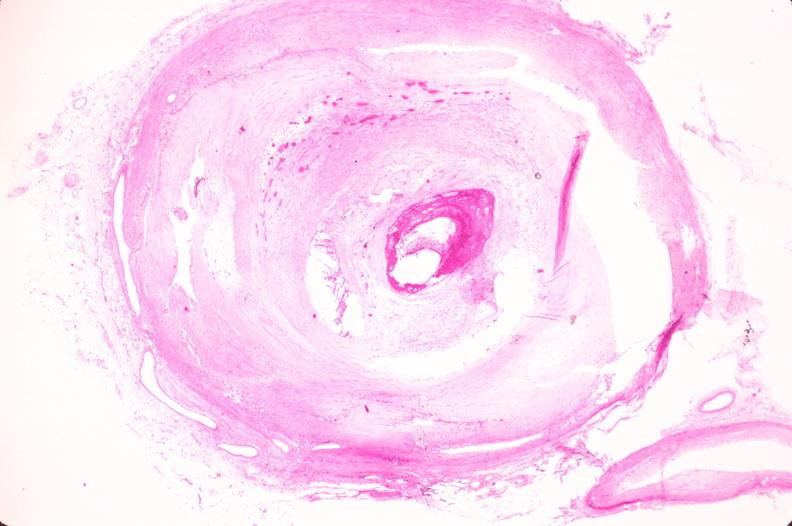what is present?
Answer the question using a single word or phrase. Cardiovascular 